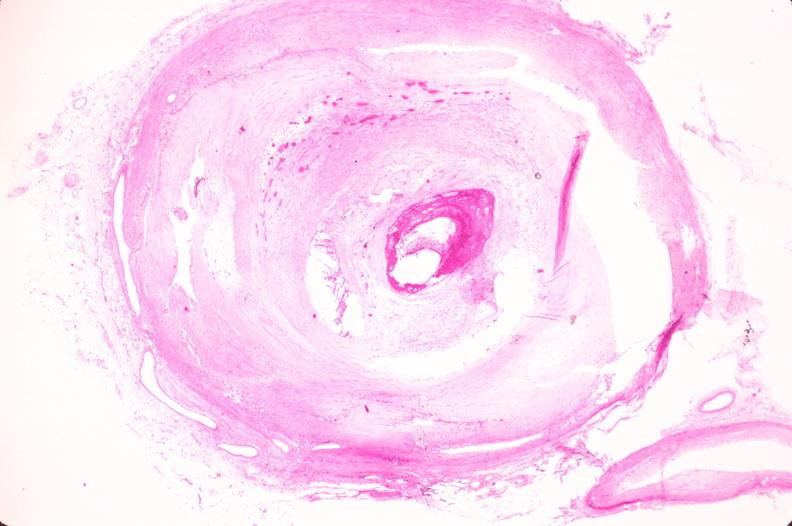what is present?
Answer the question using a single word or phrase. Cardiovascular 